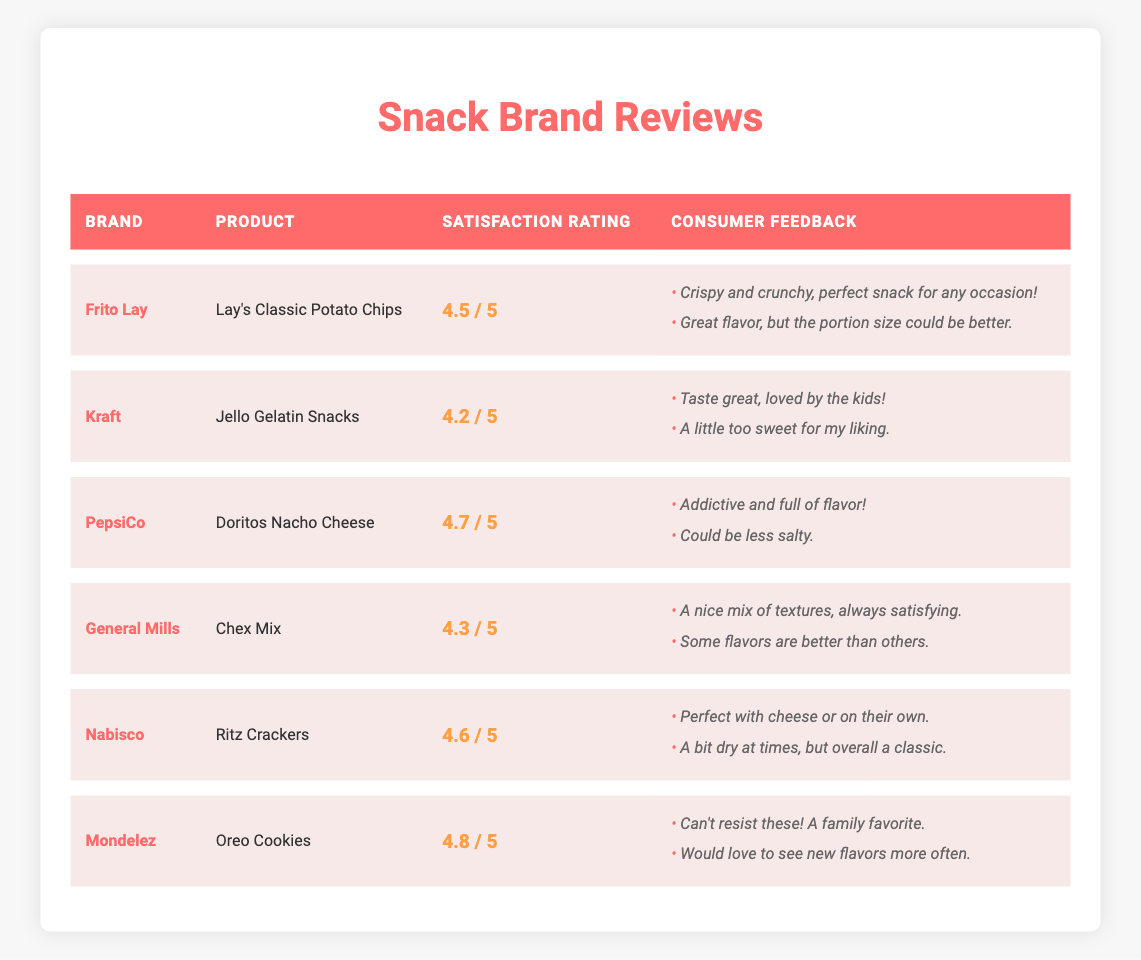What is the consumer satisfaction rating for Frito Lay's Lay's Classic Potato Chips? According to the table, the rating for Frito Lay's Lay's Classic Potato Chips is directly listed under the "Satisfaction Rating" column, which shows 4.5.
Answer: 4.5 Which snack brand received the highest consumer satisfaction rating? The highest rating in the table is 4.8, which corresponds to Mondelez's Oreo Cookies, as we can see that their rating is the highest among all the listed products.
Answer: Mondelez Is the feedback for Ritz Crackers generally positive? The feedback provided for Ritz Crackers includes phrases like "Perfect with cheese or on their own" and "A bit dry at times, but overall a classic." Despite mentioning dryness, the first part is largely positive, indicating that overall feedback is favorable.
Answer: Yes What is the difference in consumer satisfaction ratings between PepsiCo's Doritos Nacho Cheese and Kraft's Jello Gelatin Snacks? PepsiCo's Doritos Nacho Cheese has a rating of 4.7, while Kraft's Jello Gelatin Snacks has a rating of 4.2. To find the difference, subtract 4.2 from 4.7, which gives us 0.5.
Answer: 0.5 How many snack brands have a consumer satisfaction rating of 4.5 or higher? Looking at the table, we note the ratings: Frito Lay (4.5), Kraft (4.2), PepsiCo (4.7), General Mills (4.3), Nabisco (4.6), and Mondelez (4.8). The brands with ratings of 4.5 or higher are Frito Lay, PepsiCo, Nabisco, and Mondelez. Thus, there are four brands meeting this criterion.
Answer: 4 Which feedback mentioned a child's preference, and for which product? The feedback mentioning children's preference can be found under Kraft's Jello Gelatin Snacks, with the comment "Taste great, loved by the kids!" indicating a positive reception among children.
Answer: Kraft's Jello Gelatin Snacks Does any product have feedback suggesting a desire for new flavors? The feedback for Mondelez's Oreo Cookies states, "Would love to see new flavors more often," clearly indicating a desire for more flavor variety.
Answer: Yes What is the average consumer satisfaction rating of all the snack brands listed? The ratings are Frito Lay (4.5), Kraft (4.2), PepsiCo (4.7), General Mills (4.3), Nabisco (4.6), and Mondelez (4.8). Adding these gives us a total of 27.1. Since there are 6 brands, we divide 27.1 by 6, resulting in an average of approximately 4.52.
Answer: 4.52 Which product has feedback mentioning its addictive nature? In the table, the feedback for PepsiCo's Doritos Nacho Cheese states, "Addictive and full of flavor!" which highlights its appealing qualities, especially in terms of taste.
Answer: Doritos Nacho Cheese 